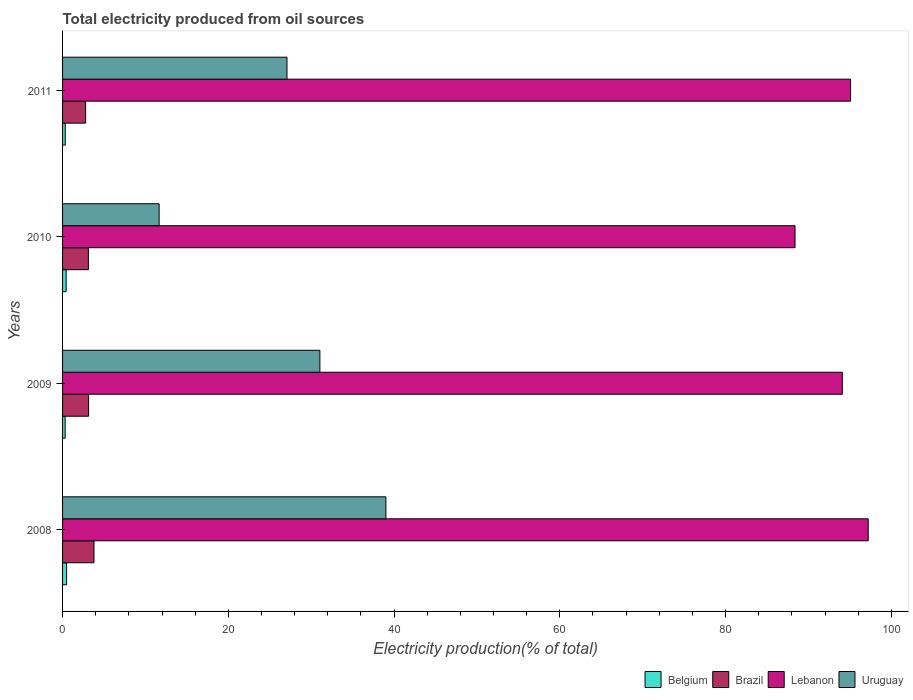How many different coloured bars are there?
Your answer should be very brief. 4. How many bars are there on the 1st tick from the top?
Your answer should be compact. 4. How many bars are there on the 2nd tick from the bottom?
Offer a very short reply. 4. In how many cases, is the number of bars for a given year not equal to the number of legend labels?
Give a very brief answer. 0. What is the total electricity produced in Lebanon in 2009?
Give a very brief answer. 94.08. Across all years, what is the maximum total electricity produced in Lebanon?
Your answer should be very brief. 97.21. Across all years, what is the minimum total electricity produced in Brazil?
Keep it short and to the point. 2.78. What is the total total electricity produced in Brazil in the graph?
Keep it short and to the point. 12.83. What is the difference between the total electricity produced in Lebanon in 2010 and that in 2011?
Ensure brevity in your answer.  -6.7. What is the difference between the total electricity produced in Lebanon in 2011 and the total electricity produced in Uruguay in 2008?
Your answer should be very brief. 56.07. What is the average total electricity produced in Brazil per year?
Offer a very short reply. 3.21. In the year 2011, what is the difference between the total electricity produced in Brazil and total electricity produced in Uruguay?
Offer a terse response. -24.3. In how many years, is the total electricity produced in Uruguay greater than 40 %?
Offer a very short reply. 0. What is the ratio of the total electricity produced in Brazil in 2008 to that in 2010?
Your response must be concise. 1.22. Is the total electricity produced in Belgium in 2010 less than that in 2011?
Ensure brevity in your answer.  No. What is the difference between the highest and the second highest total electricity produced in Brazil?
Your answer should be very brief. 0.65. What is the difference between the highest and the lowest total electricity produced in Brazil?
Your answer should be very brief. 1.01. In how many years, is the total electricity produced in Brazil greater than the average total electricity produced in Brazil taken over all years?
Give a very brief answer. 1. Is the sum of the total electricity produced in Belgium in 2010 and 2011 greater than the maximum total electricity produced in Lebanon across all years?
Keep it short and to the point. No. What does the 2nd bar from the top in 2011 represents?
Provide a succinct answer. Lebanon. What does the 3rd bar from the bottom in 2010 represents?
Make the answer very short. Lebanon. Is it the case that in every year, the sum of the total electricity produced in Belgium and total electricity produced in Lebanon is greater than the total electricity produced in Uruguay?
Your answer should be very brief. Yes. How many years are there in the graph?
Offer a very short reply. 4. Are the values on the major ticks of X-axis written in scientific E-notation?
Offer a terse response. No. Does the graph contain any zero values?
Ensure brevity in your answer.  No. Does the graph contain grids?
Your answer should be compact. No. Where does the legend appear in the graph?
Offer a very short reply. Bottom right. How many legend labels are there?
Offer a very short reply. 4. How are the legend labels stacked?
Your response must be concise. Horizontal. What is the title of the graph?
Offer a very short reply. Total electricity produced from oil sources. Does "China" appear as one of the legend labels in the graph?
Provide a succinct answer. No. What is the label or title of the X-axis?
Your answer should be very brief. Electricity production(% of total). What is the Electricity production(% of total) in Belgium in 2008?
Offer a terse response. 0.49. What is the Electricity production(% of total) of Brazil in 2008?
Your answer should be compact. 3.79. What is the Electricity production(% of total) of Lebanon in 2008?
Offer a terse response. 97.21. What is the Electricity production(% of total) in Uruguay in 2008?
Offer a very short reply. 39.01. What is the Electricity production(% of total) in Belgium in 2009?
Your response must be concise. 0.31. What is the Electricity production(% of total) in Brazil in 2009?
Your answer should be compact. 3.14. What is the Electricity production(% of total) of Lebanon in 2009?
Your answer should be compact. 94.08. What is the Electricity production(% of total) of Uruguay in 2009?
Offer a terse response. 31.05. What is the Electricity production(% of total) in Belgium in 2010?
Your response must be concise. 0.43. What is the Electricity production(% of total) of Brazil in 2010?
Ensure brevity in your answer.  3.11. What is the Electricity production(% of total) of Lebanon in 2010?
Provide a short and direct response. 88.38. What is the Electricity production(% of total) of Uruguay in 2010?
Keep it short and to the point. 11.65. What is the Electricity production(% of total) in Belgium in 2011?
Your response must be concise. 0.33. What is the Electricity production(% of total) in Brazil in 2011?
Your response must be concise. 2.78. What is the Electricity production(% of total) in Lebanon in 2011?
Give a very brief answer. 95.08. What is the Electricity production(% of total) of Uruguay in 2011?
Provide a short and direct response. 27.08. Across all years, what is the maximum Electricity production(% of total) in Belgium?
Your answer should be very brief. 0.49. Across all years, what is the maximum Electricity production(% of total) in Brazil?
Provide a succinct answer. 3.79. Across all years, what is the maximum Electricity production(% of total) in Lebanon?
Give a very brief answer. 97.21. Across all years, what is the maximum Electricity production(% of total) of Uruguay?
Your response must be concise. 39.01. Across all years, what is the minimum Electricity production(% of total) of Belgium?
Offer a very short reply. 0.31. Across all years, what is the minimum Electricity production(% of total) of Brazil?
Offer a very short reply. 2.78. Across all years, what is the minimum Electricity production(% of total) in Lebanon?
Provide a succinct answer. 88.38. Across all years, what is the minimum Electricity production(% of total) of Uruguay?
Your answer should be compact. 11.65. What is the total Electricity production(% of total) of Belgium in the graph?
Offer a terse response. 1.56. What is the total Electricity production(% of total) of Brazil in the graph?
Provide a short and direct response. 12.83. What is the total Electricity production(% of total) in Lebanon in the graph?
Provide a succinct answer. 374.75. What is the total Electricity production(% of total) in Uruguay in the graph?
Your answer should be very brief. 108.79. What is the difference between the Electricity production(% of total) of Belgium in 2008 and that in 2009?
Your response must be concise. 0.17. What is the difference between the Electricity production(% of total) of Brazil in 2008 and that in 2009?
Your answer should be very brief. 0.65. What is the difference between the Electricity production(% of total) of Lebanon in 2008 and that in 2009?
Offer a terse response. 3.13. What is the difference between the Electricity production(% of total) in Uruguay in 2008 and that in 2009?
Offer a terse response. 7.96. What is the difference between the Electricity production(% of total) in Belgium in 2008 and that in 2010?
Your answer should be very brief. 0.05. What is the difference between the Electricity production(% of total) of Brazil in 2008 and that in 2010?
Keep it short and to the point. 0.68. What is the difference between the Electricity production(% of total) in Lebanon in 2008 and that in 2010?
Your response must be concise. 8.83. What is the difference between the Electricity production(% of total) in Uruguay in 2008 and that in 2010?
Your answer should be very brief. 27.36. What is the difference between the Electricity production(% of total) in Belgium in 2008 and that in 2011?
Your answer should be very brief. 0.16. What is the difference between the Electricity production(% of total) of Brazil in 2008 and that in 2011?
Ensure brevity in your answer.  1.01. What is the difference between the Electricity production(% of total) in Lebanon in 2008 and that in 2011?
Your answer should be compact. 2.13. What is the difference between the Electricity production(% of total) of Uruguay in 2008 and that in 2011?
Make the answer very short. 11.93. What is the difference between the Electricity production(% of total) in Belgium in 2009 and that in 2010?
Keep it short and to the point. -0.12. What is the difference between the Electricity production(% of total) in Brazil in 2009 and that in 2010?
Make the answer very short. 0.03. What is the difference between the Electricity production(% of total) of Lebanon in 2009 and that in 2010?
Offer a terse response. 5.7. What is the difference between the Electricity production(% of total) of Uruguay in 2009 and that in 2010?
Provide a succinct answer. 19.4. What is the difference between the Electricity production(% of total) in Belgium in 2009 and that in 2011?
Make the answer very short. -0.01. What is the difference between the Electricity production(% of total) of Brazil in 2009 and that in 2011?
Your response must be concise. 0.36. What is the difference between the Electricity production(% of total) of Lebanon in 2009 and that in 2011?
Provide a succinct answer. -1. What is the difference between the Electricity production(% of total) in Uruguay in 2009 and that in 2011?
Your answer should be very brief. 3.97. What is the difference between the Electricity production(% of total) in Belgium in 2010 and that in 2011?
Keep it short and to the point. 0.11. What is the difference between the Electricity production(% of total) in Brazil in 2010 and that in 2011?
Your response must be concise. 0.33. What is the difference between the Electricity production(% of total) of Lebanon in 2010 and that in 2011?
Offer a very short reply. -6.7. What is the difference between the Electricity production(% of total) in Uruguay in 2010 and that in 2011?
Your answer should be very brief. -15.43. What is the difference between the Electricity production(% of total) in Belgium in 2008 and the Electricity production(% of total) in Brazil in 2009?
Give a very brief answer. -2.65. What is the difference between the Electricity production(% of total) in Belgium in 2008 and the Electricity production(% of total) in Lebanon in 2009?
Make the answer very short. -93.6. What is the difference between the Electricity production(% of total) of Belgium in 2008 and the Electricity production(% of total) of Uruguay in 2009?
Make the answer very short. -30.56. What is the difference between the Electricity production(% of total) in Brazil in 2008 and the Electricity production(% of total) in Lebanon in 2009?
Your response must be concise. -90.29. What is the difference between the Electricity production(% of total) of Brazil in 2008 and the Electricity production(% of total) of Uruguay in 2009?
Offer a terse response. -27.26. What is the difference between the Electricity production(% of total) of Lebanon in 2008 and the Electricity production(% of total) of Uruguay in 2009?
Offer a terse response. 66.16. What is the difference between the Electricity production(% of total) in Belgium in 2008 and the Electricity production(% of total) in Brazil in 2010?
Your answer should be compact. -2.63. What is the difference between the Electricity production(% of total) of Belgium in 2008 and the Electricity production(% of total) of Lebanon in 2010?
Provide a short and direct response. -87.89. What is the difference between the Electricity production(% of total) of Belgium in 2008 and the Electricity production(% of total) of Uruguay in 2010?
Provide a short and direct response. -11.16. What is the difference between the Electricity production(% of total) in Brazil in 2008 and the Electricity production(% of total) in Lebanon in 2010?
Keep it short and to the point. -84.59. What is the difference between the Electricity production(% of total) of Brazil in 2008 and the Electricity production(% of total) of Uruguay in 2010?
Your answer should be very brief. -7.86. What is the difference between the Electricity production(% of total) of Lebanon in 2008 and the Electricity production(% of total) of Uruguay in 2010?
Your answer should be compact. 85.56. What is the difference between the Electricity production(% of total) in Belgium in 2008 and the Electricity production(% of total) in Brazil in 2011?
Offer a very short reply. -2.3. What is the difference between the Electricity production(% of total) of Belgium in 2008 and the Electricity production(% of total) of Lebanon in 2011?
Make the answer very short. -94.6. What is the difference between the Electricity production(% of total) of Belgium in 2008 and the Electricity production(% of total) of Uruguay in 2011?
Provide a succinct answer. -26.59. What is the difference between the Electricity production(% of total) in Brazil in 2008 and the Electricity production(% of total) in Lebanon in 2011?
Give a very brief answer. -91.29. What is the difference between the Electricity production(% of total) of Brazil in 2008 and the Electricity production(% of total) of Uruguay in 2011?
Offer a terse response. -23.29. What is the difference between the Electricity production(% of total) in Lebanon in 2008 and the Electricity production(% of total) in Uruguay in 2011?
Your response must be concise. 70.13. What is the difference between the Electricity production(% of total) of Belgium in 2009 and the Electricity production(% of total) of Brazil in 2010?
Your answer should be compact. -2.8. What is the difference between the Electricity production(% of total) of Belgium in 2009 and the Electricity production(% of total) of Lebanon in 2010?
Your answer should be compact. -88.07. What is the difference between the Electricity production(% of total) in Belgium in 2009 and the Electricity production(% of total) in Uruguay in 2010?
Give a very brief answer. -11.34. What is the difference between the Electricity production(% of total) in Brazil in 2009 and the Electricity production(% of total) in Lebanon in 2010?
Give a very brief answer. -85.24. What is the difference between the Electricity production(% of total) in Brazil in 2009 and the Electricity production(% of total) in Uruguay in 2010?
Your answer should be compact. -8.51. What is the difference between the Electricity production(% of total) in Lebanon in 2009 and the Electricity production(% of total) in Uruguay in 2010?
Keep it short and to the point. 82.43. What is the difference between the Electricity production(% of total) in Belgium in 2009 and the Electricity production(% of total) in Brazil in 2011?
Offer a very short reply. -2.47. What is the difference between the Electricity production(% of total) of Belgium in 2009 and the Electricity production(% of total) of Lebanon in 2011?
Your answer should be compact. -94.77. What is the difference between the Electricity production(% of total) of Belgium in 2009 and the Electricity production(% of total) of Uruguay in 2011?
Keep it short and to the point. -26.77. What is the difference between the Electricity production(% of total) of Brazil in 2009 and the Electricity production(% of total) of Lebanon in 2011?
Your answer should be compact. -91.94. What is the difference between the Electricity production(% of total) in Brazil in 2009 and the Electricity production(% of total) in Uruguay in 2011?
Your answer should be compact. -23.94. What is the difference between the Electricity production(% of total) in Lebanon in 2009 and the Electricity production(% of total) in Uruguay in 2011?
Provide a succinct answer. 67. What is the difference between the Electricity production(% of total) of Belgium in 2010 and the Electricity production(% of total) of Brazil in 2011?
Offer a terse response. -2.35. What is the difference between the Electricity production(% of total) in Belgium in 2010 and the Electricity production(% of total) in Lebanon in 2011?
Offer a very short reply. -94.65. What is the difference between the Electricity production(% of total) of Belgium in 2010 and the Electricity production(% of total) of Uruguay in 2011?
Give a very brief answer. -26.65. What is the difference between the Electricity production(% of total) in Brazil in 2010 and the Electricity production(% of total) in Lebanon in 2011?
Provide a succinct answer. -91.97. What is the difference between the Electricity production(% of total) in Brazil in 2010 and the Electricity production(% of total) in Uruguay in 2011?
Your answer should be compact. -23.96. What is the difference between the Electricity production(% of total) in Lebanon in 2010 and the Electricity production(% of total) in Uruguay in 2011?
Provide a succinct answer. 61.3. What is the average Electricity production(% of total) in Belgium per year?
Provide a succinct answer. 0.39. What is the average Electricity production(% of total) of Brazil per year?
Your answer should be very brief. 3.21. What is the average Electricity production(% of total) in Lebanon per year?
Make the answer very short. 93.69. What is the average Electricity production(% of total) of Uruguay per year?
Ensure brevity in your answer.  27.2. In the year 2008, what is the difference between the Electricity production(% of total) in Belgium and Electricity production(% of total) in Brazil?
Give a very brief answer. -3.31. In the year 2008, what is the difference between the Electricity production(% of total) of Belgium and Electricity production(% of total) of Lebanon?
Ensure brevity in your answer.  -96.72. In the year 2008, what is the difference between the Electricity production(% of total) in Belgium and Electricity production(% of total) in Uruguay?
Offer a very short reply. -38.53. In the year 2008, what is the difference between the Electricity production(% of total) in Brazil and Electricity production(% of total) in Lebanon?
Ensure brevity in your answer.  -93.42. In the year 2008, what is the difference between the Electricity production(% of total) of Brazil and Electricity production(% of total) of Uruguay?
Provide a short and direct response. -35.22. In the year 2008, what is the difference between the Electricity production(% of total) in Lebanon and Electricity production(% of total) in Uruguay?
Offer a very short reply. 58.19. In the year 2009, what is the difference between the Electricity production(% of total) in Belgium and Electricity production(% of total) in Brazil?
Ensure brevity in your answer.  -2.83. In the year 2009, what is the difference between the Electricity production(% of total) of Belgium and Electricity production(% of total) of Lebanon?
Provide a short and direct response. -93.77. In the year 2009, what is the difference between the Electricity production(% of total) in Belgium and Electricity production(% of total) in Uruguay?
Offer a terse response. -30.74. In the year 2009, what is the difference between the Electricity production(% of total) of Brazil and Electricity production(% of total) of Lebanon?
Your answer should be compact. -90.94. In the year 2009, what is the difference between the Electricity production(% of total) in Brazil and Electricity production(% of total) in Uruguay?
Your response must be concise. -27.91. In the year 2009, what is the difference between the Electricity production(% of total) in Lebanon and Electricity production(% of total) in Uruguay?
Your answer should be compact. 63.03. In the year 2010, what is the difference between the Electricity production(% of total) of Belgium and Electricity production(% of total) of Brazil?
Your response must be concise. -2.68. In the year 2010, what is the difference between the Electricity production(% of total) of Belgium and Electricity production(% of total) of Lebanon?
Your response must be concise. -87.95. In the year 2010, what is the difference between the Electricity production(% of total) of Belgium and Electricity production(% of total) of Uruguay?
Your answer should be compact. -11.22. In the year 2010, what is the difference between the Electricity production(% of total) in Brazil and Electricity production(% of total) in Lebanon?
Your answer should be very brief. -85.26. In the year 2010, what is the difference between the Electricity production(% of total) in Brazil and Electricity production(% of total) in Uruguay?
Keep it short and to the point. -8.54. In the year 2010, what is the difference between the Electricity production(% of total) in Lebanon and Electricity production(% of total) in Uruguay?
Give a very brief answer. 76.73. In the year 2011, what is the difference between the Electricity production(% of total) of Belgium and Electricity production(% of total) of Brazil?
Make the answer very short. -2.46. In the year 2011, what is the difference between the Electricity production(% of total) of Belgium and Electricity production(% of total) of Lebanon?
Provide a short and direct response. -94.76. In the year 2011, what is the difference between the Electricity production(% of total) in Belgium and Electricity production(% of total) in Uruguay?
Offer a very short reply. -26.75. In the year 2011, what is the difference between the Electricity production(% of total) in Brazil and Electricity production(% of total) in Lebanon?
Make the answer very short. -92.3. In the year 2011, what is the difference between the Electricity production(% of total) in Brazil and Electricity production(% of total) in Uruguay?
Keep it short and to the point. -24.3. In the year 2011, what is the difference between the Electricity production(% of total) in Lebanon and Electricity production(% of total) in Uruguay?
Ensure brevity in your answer.  68. What is the ratio of the Electricity production(% of total) in Belgium in 2008 to that in 2009?
Your answer should be compact. 1.56. What is the ratio of the Electricity production(% of total) of Brazil in 2008 to that in 2009?
Your response must be concise. 1.21. What is the ratio of the Electricity production(% of total) in Lebanon in 2008 to that in 2009?
Ensure brevity in your answer.  1.03. What is the ratio of the Electricity production(% of total) of Uruguay in 2008 to that in 2009?
Ensure brevity in your answer.  1.26. What is the ratio of the Electricity production(% of total) in Belgium in 2008 to that in 2010?
Provide a short and direct response. 1.12. What is the ratio of the Electricity production(% of total) of Brazil in 2008 to that in 2010?
Keep it short and to the point. 1.22. What is the ratio of the Electricity production(% of total) of Lebanon in 2008 to that in 2010?
Give a very brief answer. 1.1. What is the ratio of the Electricity production(% of total) in Uruguay in 2008 to that in 2010?
Ensure brevity in your answer.  3.35. What is the ratio of the Electricity production(% of total) of Belgium in 2008 to that in 2011?
Your answer should be very brief. 1.49. What is the ratio of the Electricity production(% of total) of Brazil in 2008 to that in 2011?
Offer a terse response. 1.36. What is the ratio of the Electricity production(% of total) of Lebanon in 2008 to that in 2011?
Keep it short and to the point. 1.02. What is the ratio of the Electricity production(% of total) of Uruguay in 2008 to that in 2011?
Keep it short and to the point. 1.44. What is the ratio of the Electricity production(% of total) in Belgium in 2009 to that in 2010?
Offer a terse response. 0.72. What is the ratio of the Electricity production(% of total) of Brazil in 2009 to that in 2010?
Provide a short and direct response. 1.01. What is the ratio of the Electricity production(% of total) of Lebanon in 2009 to that in 2010?
Give a very brief answer. 1.06. What is the ratio of the Electricity production(% of total) of Uruguay in 2009 to that in 2010?
Offer a very short reply. 2.66. What is the ratio of the Electricity production(% of total) of Brazil in 2009 to that in 2011?
Offer a very short reply. 1.13. What is the ratio of the Electricity production(% of total) in Lebanon in 2009 to that in 2011?
Offer a very short reply. 0.99. What is the ratio of the Electricity production(% of total) in Uruguay in 2009 to that in 2011?
Provide a succinct answer. 1.15. What is the ratio of the Electricity production(% of total) of Belgium in 2010 to that in 2011?
Provide a short and direct response. 1.33. What is the ratio of the Electricity production(% of total) in Brazil in 2010 to that in 2011?
Your answer should be very brief. 1.12. What is the ratio of the Electricity production(% of total) of Lebanon in 2010 to that in 2011?
Your answer should be compact. 0.93. What is the ratio of the Electricity production(% of total) of Uruguay in 2010 to that in 2011?
Give a very brief answer. 0.43. What is the difference between the highest and the second highest Electricity production(% of total) of Belgium?
Provide a succinct answer. 0.05. What is the difference between the highest and the second highest Electricity production(% of total) in Brazil?
Your response must be concise. 0.65. What is the difference between the highest and the second highest Electricity production(% of total) of Lebanon?
Make the answer very short. 2.13. What is the difference between the highest and the second highest Electricity production(% of total) of Uruguay?
Offer a very short reply. 7.96. What is the difference between the highest and the lowest Electricity production(% of total) of Belgium?
Offer a very short reply. 0.17. What is the difference between the highest and the lowest Electricity production(% of total) of Brazil?
Provide a short and direct response. 1.01. What is the difference between the highest and the lowest Electricity production(% of total) of Lebanon?
Provide a short and direct response. 8.83. What is the difference between the highest and the lowest Electricity production(% of total) in Uruguay?
Give a very brief answer. 27.36. 